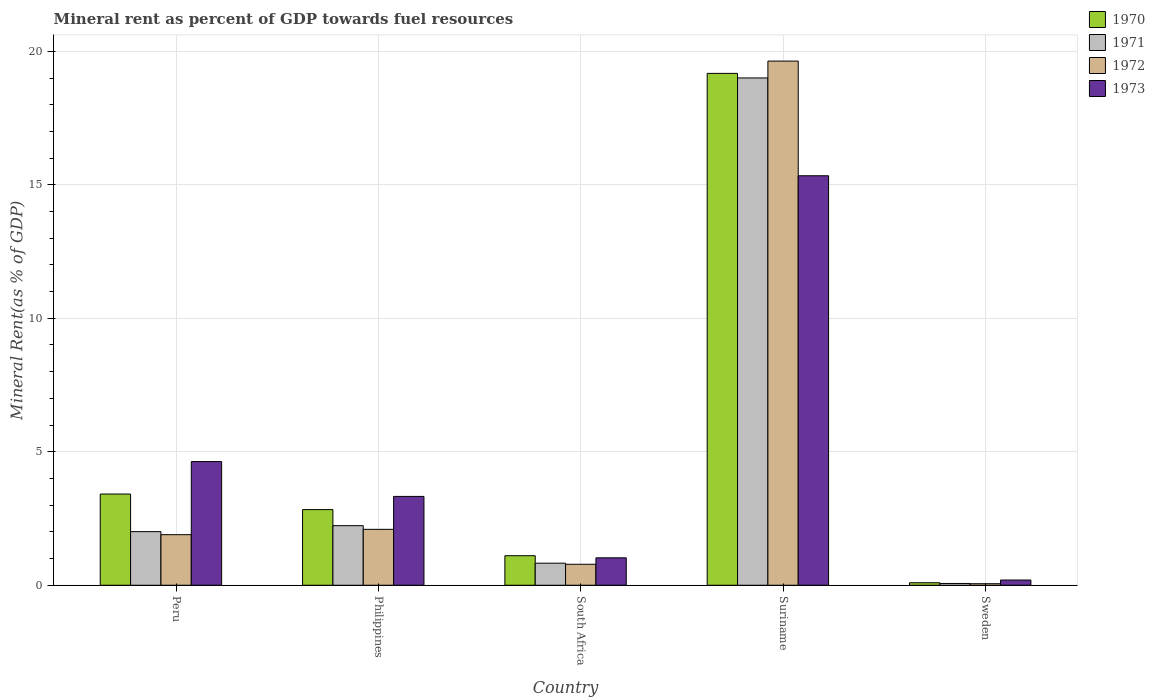How many different coloured bars are there?
Provide a succinct answer. 4. How many groups of bars are there?
Make the answer very short. 5. Are the number of bars per tick equal to the number of legend labels?
Keep it short and to the point. Yes. Are the number of bars on each tick of the X-axis equal?
Ensure brevity in your answer.  Yes. How many bars are there on the 3rd tick from the left?
Your response must be concise. 4. How many bars are there on the 5th tick from the right?
Provide a succinct answer. 4. What is the label of the 3rd group of bars from the left?
Provide a short and direct response. South Africa. In how many cases, is the number of bars for a given country not equal to the number of legend labels?
Give a very brief answer. 0. What is the mineral rent in 1972 in Sweden?
Ensure brevity in your answer.  0.06. Across all countries, what is the maximum mineral rent in 1972?
Keep it short and to the point. 19.63. Across all countries, what is the minimum mineral rent in 1970?
Provide a short and direct response. 0.09. In which country was the mineral rent in 1972 maximum?
Make the answer very short. Suriname. In which country was the mineral rent in 1970 minimum?
Give a very brief answer. Sweden. What is the total mineral rent in 1970 in the graph?
Your response must be concise. 26.62. What is the difference between the mineral rent in 1972 in South Africa and that in Suriname?
Your answer should be very brief. -18.85. What is the difference between the mineral rent in 1971 in Peru and the mineral rent in 1970 in Philippines?
Your answer should be very brief. -0.83. What is the average mineral rent in 1971 per country?
Give a very brief answer. 4.83. What is the difference between the mineral rent of/in 1973 and mineral rent of/in 1972 in South Africa?
Keep it short and to the point. 0.24. What is the ratio of the mineral rent in 1973 in Philippines to that in Suriname?
Ensure brevity in your answer.  0.22. Is the mineral rent in 1971 in South Africa less than that in Sweden?
Keep it short and to the point. No. What is the difference between the highest and the second highest mineral rent in 1970?
Your response must be concise. 0.58. What is the difference between the highest and the lowest mineral rent in 1972?
Your response must be concise. 19.58. In how many countries, is the mineral rent in 1972 greater than the average mineral rent in 1972 taken over all countries?
Provide a short and direct response. 1. Is the sum of the mineral rent in 1973 in South Africa and Sweden greater than the maximum mineral rent in 1972 across all countries?
Your answer should be compact. No. What does the 1st bar from the left in Suriname represents?
Provide a succinct answer. 1970. How many bars are there?
Make the answer very short. 20. How many countries are there in the graph?
Provide a short and direct response. 5. Does the graph contain grids?
Provide a short and direct response. Yes. How many legend labels are there?
Your response must be concise. 4. How are the legend labels stacked?
Offer a terse response. Vertical. What is the title of the graph?
Offer a terse response. Mineral rent as percent of GDP towards fuel resources. Does "2001" appear as one of the legend labels in the graph?
Your answer should be very brief. No. What is the label or title of the X-axis?
Offer a very short reply. Country. What is the label or title of the Y-axis?
Offer a terse response. Mineral Rent(as % of GDP). What is the Mineral Rent(as % of GDP) of 1970 in Peru?
Offer a terse response. 3.42. What is the Mineral Rent(as % of GDP) of 1971 in Peru?
Keep it short and to the point. 2.01. What is the Mineral Rent(as % of GDP) of 1972 in Peru?
Your response must be concise. 1.89. What is the Mineral Rent(as % of GDP) in 1973 in Peru?
Provide a succinct answer. 4.63. What is the Mineral Rent(as % of GDP) of 1970 in Philippines?
Your response must be concise. 2.83. What is the Mineral Rent(as % of GDP) of 1971 in Philippines?
Provide a succinct answer. 2.23. What is the Mineral Rent(as % of GDP) of 1972 in Philippines?
Keep it short and to the point. 2.09. What is the Mineral Rent(as % of GDP) of 1973 in Philippines?
Your answer should be compact. 3.33. What is the Mineral Rent(as % of GDP) of 1970 in South Africa?
Offer a very short reply. 1.11. What is the Mineral Rent(as % of GDP) in 1971 in South Africa?
Provide a short and direct response. 0.83. What is the Mineral Rent(as % of GDP) in 1972 in South Africa?
Make the answer very short. 0.79. What is the Mineral Rent(as % of GDP) in 1973 in South Africa?
Ensure brevity in your answer.  1.03. What is the Mineral Rent(as % of GDP) in 1970 in Suriname?
Offer a terse response. 19.17. What is the Mineral Rent(as % of GDP) of 1971 in Suriname?
Your response must be concise. 19. What is the Mineral Rent(as % of GDP) of 1972 in Suriname?
Offer a terse response. 19.63. What is the Mineral Rent(as % of GDP) in 1973 in Suriname?
Your answer should be very brief. 15.34. What is the Mineral Rent(as % of GDP) of 1970 in Sweden?
Your answer should be compact. 0.09. What is the Mineral Rent(as % of GDP) of 1971 in Sweden?
Provide a succinct answer. 0.07. What is the Mineral Rent(as % of GDP) in 1972 in Sweden?
Your answer should be very brief. 0.06. What is the Mineral Rent(as % of GDP) in 1973 in Sweden?
Offer a very short reply. 0.2. Across all countries, what is the maximum Mineral Rent(as % of GDP) in 1970?
Your response must be concise. 19.17. Across all countries, what is the maximum Mineral Rent(as % of GDP) in 1971?
Your response must be concise. 19. Across all countries, what is the maximum Mineral Rent(as % of GDP) in 1972?
Make the answer very short. 19.63. Across all countries, what is the maximum Mineral Rent(as % of GDP) in 1973?
Your answer should be very brief. 15.34. Across all countries, what is the minimum Mineral Rent(as % of GDP) of 1970?
Give a very brief answer. 0.09. Across all countries, what is the minimum Mineral Rent(as % of GDP) in 1971?
Offer a very short reply. 0.07. Across all countries, what is the minimum Mineral Rent(as % of GDP) of 1972?
Offer a very short reply. 0.06. Across all countries, what is the minimum Mineral Rent(as % of GDP) of 1973?
Provide a short and direct response. 0.2. What is the total Mineral Rent(as % of GDP) in 1970 in the graph?
Give a very brief answer. 26.62. What is the total Mineral Rent(as % of GDP) in 1971 in the graph?
Offer a very short reply. 24.13. What is the total Mineral Rent(as % of GDP) in 1972 in the graph?
Your answer should be compact. 24.46. What is the total Mineral Rent(as % of GDP) in 1973 in the graph?
Give a very brief answer. 24.52. What is the difference between the Mineral Rent(as % of GDP) of 1970 in Peru and that in Philippines?
Give a very brief answer. 0.58. What is the difference between the Mineral Rent(as % of GDP) of 1971 in Peru and that in Philippines?
Your answer should be compact. -0.22. What is the difference between the Mineral Rent(as % of GDP) of 1972 in Peru and that in Philippines?
Make the answer very short. -0.2. What is the difference between the Mineral Rent(as % of GDP) of 1973 in Peru and that in Philippines?
Your answer should be compact. 1.31. What is the difference between the Mineral Rent(as % of GDP) of 1970 in Peru and that in South Africa?
Your answer should be compact. 2.31. What is the difference between the Mineral Rent(as % of GDP) in 1971 in Peru and that in South Africa?
Give a very brief answer. 1.18. What is the difference between the Mineral Rent(as % of GDP) in 1972 in Peru and that in South Africa?
Your response must be concise. 1.11. What is the difference between the Mineral Rent(as % of GDP) of 1973 in Peru and that in South Africa?
Your answer should be very brief. 3.61. What is the difference between the Mineral Rent(as % of GDP) of 1970 in Peru and that in Suriname?
Ensure brevity in your answer.  -15.76. What is the difference between the Mineral Rent(as % of GDP) of 1971 in Peru and that in Suriname?
Give a very brief answer. -16.99. What is the difference between the Mineral Rent(as % of GDP) in 1972 in Peru and that in Suriname?
Offer a very short reply. -17.74. What is the difference between the Mineral Rent(as % of GDP) of 1973 in Peru and that in Suriname?
Keep it short and to the point. -10.71. What is the difference between the Mineral Rent(as % of GDP) of 1970 in Peru and that in Sweden?
Ensure brevity in your answer.  3.32. What is the difference between the Mineral Rent(as % of GDP) in 1971 in Peru and that in Sweden?
Your answer should be compact. 1.94. What is the difference between the Mineral Rent(as % of GDP) of 1972 in Peru and that in Sweden?
Provide a succinct answer. 1.84. What is the difference between the Mineral Rent(as % of GDP) of 1973 in Peru and that in Sweden?
Offer a very short reply. 4.44. What is the difference between the Mineral Rent(as % of GDP) in 1970 in Philippines and that in South Africa?
Provide a succinct answer. 1.73. What is the difference between the Mineral Rent(as % of GDP) in 1971 in Philippines and that in South Africa?
Provide a short and direct response. 1.41. What is the difference between the Mineral Rent(as % of GDP) of 1972 in Philippines and that in South Africa?
Your answer should be very brief. 1.31. What is the difference between the Mineral Rent(as % of GDP) in 1973 in Philippines and that in South Africa?
Offer a terse response. 2.3. What is the difference between the Mineral Rent(as % of GDP) of 1970 in Philippines and that in Suriname?
Ensure brevity in your answer.  -16.34. What is the difference between the Mineral Rent(as % of GDP) of 1971 in Philippines and that in Suriname?
Offer a very short reply. -16.77. What is the difference between the Mineral Rent(as % of GDP) in 1972 in Philippines and that in Suriname?
Offer a terse response. -17.54. What is the difference between the Mineral Rent(as % of GDP) in 1973 in Philippines and that in Suriname?
Your answer should be very brief. -12.01. What is the difference between the Mineral Rent(as % of GDP) of 1970 in Philippines and that in Sweden?
Your answer should be compact. 2.74. What is the difference between the Mineral Rent(as % of GDP) of 1971 in Philippines and that in Sweden?
Your answer should be compact. 2.17. What is the difference between the Mineral Rent(as % of GDP) in 1972 in Philippines and that in Sweden?
Ensure brevity in your answer.  2.04. What is the difference between the Mineral Rent(as % of GDP) of 1973 in Philippines and that in Sweden?
Provide a short and direct response. 3.13. What is the difference between the Mineral Rent(as % of GDP) in 1970 in South Africa and that in Suriname?
Provide a short and direct response. -18.07. What is the difference between the Mineral Rent(as % of GDP) in 1971 in South Africa and that in Suriname?
Make the answer very short. -18.18. What is the difference between the Mineral Rent(as % of GDP) of 1972 in South Africa and that in Suriname?
Provide a short and direct response. -18.85. What is the difference between the Mineral Rent(as % of GDP) of 1973 in South Africa and that in Suriname?
Ensure brevity in your answer.  -14.31. What is the difference between the Mineral Rent(as % of GDP) of 1970 in South Africa and that in Sweden?
Give a very brief answer. 1.01. What is the difference between the Mineral Rent(as % of GDP) in 1971 in South Africa and that in Sweden?
Your answer should be very brief. 0.76. What is the difference between the Mineral Rent(as % of GDP) of 1972 in South Africa and that in Sweden?
Provide a succinct answer. 0.73. What is the difference between the Mineral Rent(as % of GDP) of 1973 in South Africa and that in Sweden?
Provide a succinct answer. 0.83. What is the difference between the Mineral Rent(as % of GDP) of 1970 in Suriname and that in Sweden?
Give a very brief answer. 19.08. What is the difference between the Mineral Rent(as % of GDP) of 1971 in Suriname and that in Sweden?
Make the answer very short. 18.94. What is the difference between the Mineral Rent(as % of GDP) in 1972 in Suriname and that in Sweden?
Offer a very short reply. 19.58. What is the difference between the Mineral Rent(as % of GDP) in 1973 in Suriname and that in Sweden?
Give a very brief answer. 15.14. What is the difference between the Mineral Rent(as % of GDP) of 1970 in Peru and the Mineral Rent(as % of GDP) of 1971 in Philippines?
Give a very brief answer. 1.18. What is the difference between the Mineral Rent(as % of GDP) of 1970 in Peru and the Mineral Rent(as % of GDP) of 1972 in Philippines?
Keep it short and to the point. 1.32. What is the difference between the Mineral Rent(as % of GDP) of 1970 in Peru and the Mineral Rent(as % of GDP) of 1973 in Philippines?
Provide a succinct answer. 0.09. What is the difference between the Mineral Rent(as % of GDP) in 1971 in Peru and the Mineral Rent(as % of GDP) in 1972 in Philippines?
Provide a succinct answer. -0.09. What is the difference between the Mineral Rent(as % of GDP) in 1971 in Peru and the Mineral Rent(as % of GDP) in 1973 in Philippines?
Provide a succinct answer. -1.32. What is the difference between the Mineral Rent(as % of GDP) in 1972 in Peru and the Mineral Rent(as % of GDP) in 1973 in Philippines?
Keep it short and to the point. -1.43. What is the difference between the Mineral Rent(as % of GDP) in 1970 in Peru and the Mineral Rent(as % of GDP) in 1971 in South Africa?
Your answer should be compact. 2.59. What is the difference between the Mineral Rent(as % of GDP) in 1970 in Peru and the Mineral Rent(as % of GDP) in 1972 in South Africa?
Your response must be concise. 2.63. What is the difference between the Mineral Rent(as % of GDP) in 1970 in Peru and the Mineral Rent(as % of GDP) in 1973 in South Africa?
Your answer should be very brief. 2.39. What is the difference between the Mineral Rent(as % of GDP) of 1971 in Peru and the Mineral Rent(as % of GDP) of 1972 in South Africa?
Your answer should be compact. 1.22. What is the difference between the Mineral Rent(as % of GDP) of 1971 in Peru and the Mineral Rent(as % of GDP) of 1973 in South Africa?
Provide a short and direct response. 0.98. What is the difference between the Mineral Rent(as % of GDP) of 1972 in Peru and the Mineral Rent(as % of GDP) of 1973 in South Africa?
Offer a very short reply. 0.87. What is the difference between the Mineral Rent(as % of GDP) in 1970 in Peru and the Mineral Rent(as % of GDP) in 1971 in Suriname?
Your answer should be very brief. -15.59. What is the difference between the Mineral Rent(as % of GDP) of 1970 in Peru and the Mineral Rent(as % of GDP) of 1972 in Suriname?
Your answer should be compact. -16.22. What is the difference between the Mineral Rent(as % of GDP) of 1970 in Peru and the Mineral Rent(as % of GDP) of 1973 in Suriname?
Make the answer very short. -11.92. What is the difference between the Mineral Rent(as % of GDP) in 1971 in Peru and the Mineral Rent(as % of GDP) in 1972 in Suriname?
Give a very brief answer. -17.63. What is the difference between the Mineral Rent(as % of GDP) of 1971 in Peru and the Mineral Rent(as % of GDP) of 1973 in Suriname?
Provide a succinct answer. -13.33. What is the difference between the Mineral Rent(as % of GDP) in 1972 in Peru and the Mineral Rent(as % of GDP) in 1973 in Suriname?
Make the answer very short. -13.44. What is the difference between the Mineral Rent(as % of GDP) in 1970 in Peru and the Mineral Rent(as % of GDP) in 1971 in Sweden?
Offer a very short reply. 3.35. What is the difference between the Mineral Rent(as % of GDP) in 1970 in Peru and the Mineral Rent(as % of GDP) in 1972 in Sweden?
Your response must be concise. 3.36. What is the difference between the Mineral Rent(as % of GDP) of 1970 in Peru and the Mineral Rent(as % of GDP) of 1973 in Sweden?
Your answer should be compact. 3.22. What is the difference between the Mineral Rent(as % of GDP) in 1971 in Peru and the Mineral Rent(as % of GDP) in 1972 in Sweden?
Keep it short and to the point. 1.95. What is the difference between the Mineral Rent(as % of GDP) of 1971 in Peru and the Mineral Rent(as % of GDP) of 1973 in Sweden?
Offer a terse response. 1.81. What is the difference between the Mineral Rent(as % of GDP) of 1972 in Peru and the Mineral Rent(as % of GDP) of 1973 in Sweden?
Provide a short and direct response. 1.7. What is the difference between the Mineral Rent(as % of GDP) in 1970 in Philippines and the Mineral Rent(as % of GDP) in 1971 in South Africa?
Make the answer very short. 2.01. What is the difference between the Mineral Rent(as % of GDP) of 1970 in Philippines and the Mineral Rent(as % of GDP) of 1972 in South Africa?
Make the answer very short. 2.05. What is the difference between the Mineral Rent(as % of GDP) of 1970 in Philippines and the Mineral Rent(as % of GDP) of 1973 in South Africa?
Provide a succinct answer. 1.81. What is the difference between the Mineral Rent(as % of GDP) of 1971 in Philippines and the Mineral Rent(as % of GDP) of 1972 in South Africa?
Offer a terse response. 1.45. What is the difference between the Mineral Rent(as % of GDP) in 1971 in Philippines and the Mineral Rent(as % of GDP) in 1973 in South Africa?
Provide a short and direct response. 1.2. What is the difference between the Mineral Rent(as % of GDP) in 1972 in Philippines and the Mineral Rent(as % of GDP) in 1973 in South Africa?
Ensure brevity in your answer.  1.07. What is the difference between the Mineral Rent(as % of GDP) in 1970 in Philippines and the Mineral Rent(as % of GDP) in 1971 in Suriname?
Your answer should be very brief. -16.17. What is the difference between the Mineral Rent(as % of GDP) in 1970 in Philippines and the Mineral Rent(as % of GDP) in 1972 in Suriname?
Offer a terse response. -16.8. What is the difference between the Mineral Rent(as % of GDP) of 1970 in Philippines and the Mineral Rent(as % of GDP) of 1973 in Suriname?
Make the answer very short. -12.51. What is the difference between the Mineral Rent(as % of GDP) of 1971 in Philippines and the Mineral Rent(as % of GDP) of 1972 in Suriname?
Offer a terse response. -17.4. What is the difference between the Mineral Rent(as % of GDP) of 1971 in Philippines and the Mineral Rent(as % of GDP) of 1973 in Suriname?
Ensure brevity in your answer.  -13.11. What is the difference between the Mineral Rent(as % of GDP) of 1972 in Philippines and the Mineral Rent(as % of GDP) of 1973 in Suriname?
Make the answer very short. -13.24. What is the difference between the Mineral Rent(as % of GDP) in 1970 in Philippines and the Mineral Rent(as % of GDP) in 1971 in Sweden?
Give a very brief answer. 2.77. What is the difference between the Mineral Rent(as % of GDP) of 1970 in Philippines and the Mineral Rent(as % of GDP) of 1972 in Sweden?
Provide a short and direct response. 2.78. What is the difference between the Mineral Rent(as % of GDP) of 1970 in Philippines and the Mineral Rent(as % of GDP) of 1973 in Sweden?
Offer a very short reply. 2.64. What is the difference between the Mineral Rent(as % of GDP) in 1971 in Philippines and the Mineral Rent(as % of GDP) in 1972 in Sweden?
Your response must be concise. 2.17. What is the difference between the Mineral Rent(as % of GDP) of 1971 in Philippines and the Mineral Rent(as % of GDP) of 1973 in Sweden?
Your answer should be compact. 2.04. What is the difference between the Mineral Rent(as % of GDP) in 1972 in Philippines and the Mineral Rent(as % of GDP) in 1973 in Sweden?
Your answer should be compact. 1.9. What is the difference between the Mineral Rent(as % of GDP) in 1970 in South Africa and the Mineral Rent(as % of GDP) in 1971 in Suriname?
Your answer should be compact. -17.9. What is the difference between the Mineral Rent(as % of GDP) of 1970 in South Africa and the Mineral Rent(as % of GDP) of 1972 in Suriname?
Give a very brief answer. -18.53. What is the difference between the Mineral Rent(as % of GDP) in 1970 in South Africa and the Mineral Rent(as % of GDP) in 1973 in Suriname?
Your answer should be compact. -14.23. What is the difference between the Mineral Rent(as % of GDP) in 1971 in South Africa and the Mineral Rent(as % of GDP) in 1972 in Suriname?
Your answer should be compact. -18.81. What is the difference between the Mineral Rent(as % of GDP) in 1971 in South Africa and the Mineral Rent(as % of GDP) in 1973 in Suriname?
Provide a succinct answer. -14.51. What is the difference between the Mineral Rent(as % of GDP) of 1972 in South Africa and the Mineral Rent(as % of GDP) of 1973 in Suriname?
Give a very brief answer. -14.55. What is the difference between the Mineral Rent(as % of GDP) in 1970 in South Africa and the Mineral Rent(as % of GDP) in 1971 in Sweden?
Your answer should be very brief. 1.04. What is the difference between the Mineral Rent(as % of GDP) in 1970 in South Africa and the Mineral Rent(as % of GDP) in 1972 in Sweden?
Keep it short and to the point. 1.05. What is the difference between the Mineral Rent(as % of GDP) of 1970 in South Africa and the Mineral Rent(as % of GDP) of 1973 in Sweden?
Keep it short and to the point. 0.91. What is the difference between the Mineral Rent(as % of GDP) of 1971 in South Africa and the Mineral Rent(as % of GDP) of 1972 in Sweden?
Your answer should be very brief. 0.77. What is the difference between the Mineral Rent(as % of GDP) of 1971 in South Africa and the Mineral Rent(as % of GDP) of 1973 in Sweden?
Your answer should be compact. 0.63. What is the difference between the Mineral Rent(as % of GDP) of 1972 in South Africa and the Mineral Rent(as % of GDP) of 1973 in Sweden?
Ensure brevity in your answer.  0.59. What is the difference between the Mineral Rent(as % of GDP) in 1970 in Suriname and the Mineral Rent(as % of GDP) in 1971 in Sweden?
Give a very brief answer. 19.11. What is the difference between the Mineral Rent(as % of GDP) in 1970 in Suriname and the Mineral Rent(as % of GDP) in 1972 in Sweden?
Ensure brevity in your answer.  19.12. What is the difference between the Mineral Rent(as % of GDP) in 1970 in Suriname and the Mineral Rent(as % of GDP) in 1973 in Sweden?
Offer a terse response. 18.98. What is the difference between the Mineral Rent(as % of GDP) of 1971 in Suriname and the Mineral Rent(as % of GDP) of 1972 in Sweden?
Give a very brief answer. 18.95. What is the difference between the Mineral Rent(as % of GDP) of 1971 in Suriname and the Mineral Rent(as % of GDP) of 1973 in Sweden?
Keep it short and to the point. 18.81. What is the difference between the Mineral Rent(as % of GDP) in 1972 in Suriname and the Mineral Rent(as % of GDP) in 1973 in Sweden?
Provide a succinct answer. 19.44. What is the average Mineral Rent(as % of GDP) in 1970 per country?
Offer a very short reply. 5.32. What is the average Mineral Rent(as % of GDP) of 1971 per country?
Provide a succinct answer. 4.83. What is the average Mineral Rent(as % of GDP) of 1972 per country?
Make the answer very short. 4.89. What is the average Mineral Rent(as % of GDP) of 1973 per country?
Ensure brevity in your answer.  4.9. What is the difference between the Mineral Rent(as % of GDP) of 1970 and Mineral Rent(as % of GDP) of 1971 in Peru?
Provide a succinct answer. 1.41. What is the difference between the Mineral Rent(as % of GDP) in 1970 and Mineral Rent(as % of GDP) in 1972 in Peru?
Make the answer very short. 1.52. What is the difference between the Mineral Rent(as % of GDP) in 1970 and Mineral Rent(as % of GDP) in 1973 in Peru?
Your answer should be very brief. -1.22. What is the difference between the Mineral Rent(as % of GDP) of 1971 and Mineral Rent(as % of GDP) of 1972 in Peru?
Your answer should be very brief. 0.11. What is the difference between the Mineral Rent(as % of GDP) in 1971 and Mineral Rent(as % of GDP) in 1973 in Peru?
Give a very brief answer. -2.62. What is the difference between the Mineral Rent(as % of GDP) of 1972 and Mineral Rent(as % of GDP) of 1973 in Peru?
Your response must be concise. -2.74. What is the difference between the Mineral Rent(as % of GDP) of 1970 and Mineral Rent(as % of GDP) of 1971 in Philippines?
Keep it short and to the point. 0.6. What is the difference between the Mineral Rent(as % of GDP) in 1970 and Mineral Rent(as % of GDP) in 1972 in Philippines?
Keep it short and to the point. 0.74. What is the difference between the Mineral Rent(as % of GDP) of 1970 and Mineral Rent(as % of GDP) of 1973 in Philippines?
Provide a short and direct response. -0.49. What is the difference between the Mineral Rent(as % of GDP) in 1971 and Mineral Rent(as % of GDP) in 1972 in Philippines?
Give a very brief answer. 0.14. What is the difference between the Mineral Rent(as % of GDP) of 1971 and Mineral Rent(as % of GDP) of 1973 in Philippines?
Give a very brief answer. -1.1. What is the difference between the Mineral Rent(as % of GDP) in 1972 and Mineral Rent(as % of GDP) in 1973 in Philippines?
Make the answer very short. -1.23. What is the difference between the Mineral Rent(as % of GDP) of 1970 and Mineral Rent(as % of GDP) of 1971 in South Africa?
Offer a very short reply. 0.28. What is the difference between the Mineral Rent(as % of GDP) of 1970 and Mineral Rent(as % of GDP) of 1972 in South Africa?
Ensure brevity in your answer.  0.32. What is the difference between the Mineral Rent(as % of GDP) in 1970 and Mineral Rent(as % of GDP) in 1973 in South Africa?
Keep it short and to the point. 0.08. What is the difference between the Mineral Rent(as % of GDP) of 1971 and Mineral Rent(as % of GDP) of 1972 in South Africa?
Provide a short and direct response. 0.04. What is the difference between the Mineral Rent(as % of GDP) of 1971 and Mineral Rent(as % of GDP) of 1973 in South Africa?
Give a very brief answer. -0.2. What is the difference between the Mineral Rent(as % of GDP) of 1972 and Mineral Rent(as % of GDP) of 1973 in South Africa?
Give a very brief answer. -0.24. What is the difference between the Mineral Rent(as % of GDP) of 1970 and Mineral Rent(as % of GDP) of 1971 in Suriname?
Keep it short and to the point. 0.17. What is the difference between the Mineral Rent(as % of GDP) of 1970 and Mineral Rent(as % of GDP) of 1972 in Suriname?
Provide a succinct answer. -0.46. What is the difference between the Mineral Rent(as % of GDP) of 1970 and Mineral Rent(as % of GDP) of 1973 in Suriname?
Keep it short and to the point. 3.84. What is the difference between the Mineral Rent(as % of GDP) in 1971 and Mineral Rent(as % of GDP) in 1972 in Suriname?
Your response must be concise. -0.63. What is the difference between the Mineral Rent(as % of GDP) of 1971 and Mineral Rent(as % of GDP) of 1973 in Suriname?
Offer a terse response. 3.66. What is the difference between the Mineral Rent(as % of GDP) in 1972 and Mineral Rent(as % of GDP) in 1973 in Suriname?
Provide a short and direct response. 4.3. What is the difference between the Mineral Rent(as % of GDP) of 1970 and Mineral Rent(as % of GDP) of 1971 in Sweden?
Your answer should be compact. 0.03. What is the difference between the Mineral Rent(as % of GDP) in 1970 and Mineral Rent(as % of GDP) in 1972 in Sweden?
Give a very brief answer. 0.04. What is the difference between the Mineral Rent(as % of GDP) of 1970 and Mineral Rent(as % of GDP) of 1973 in Sweden?
Offer a very short reply. -0.1. What is the difference between the Mineral Rent(as % of GDP) of 1971 and Mineral Rent(as % of GDP) of 1972 in Sweden?
Keep it short and to the point. 0.01. What is the difference between the Mineral Rent(as % of GDP) in 1971 and Mineral Rent(as % of GDP) in 1973 in Sweden?
Ensure brevity in your answer.  -0.13. What is the difference between the Mineral Rent(as % of GDP) of 1972 and Mineral Rent(as % of GDP) of 1973 in Sweden?
Your response must be concise. -0.14. What is the ratio of the Mineral Rent(as % of GDP) of 1970 in Peru to that in Philippines?
Keep it short and to the point. 1.21. What is the ratio of the Mineral Rent(as % of GDP) in 1971 in Peru to that in Philippines?
Offer a very short reply. 0.9. What is the ratio of the Mineral Rent(as % of GDP) of 1972 in Peru to that in Philippines?
Offer a terse response. 0.9. What is the ratio of the Mineral Rent(as % of GDP) of 1973 in Peru to that in Philippines?
Offer a very short reply. 1.39. What is the ratio of the Mineral Rent(as % of GDP) of 1970 in Peru to that in South Africa?
Make the answer very short. 3.09. What is the ratio of the Mineral Rent(as % of GDP) of 1971 in Peru to that in South Africa?
Ensure brevity in your answer.  2.43. What is the ratio of the Mineral Rent(as % of GDP) of 1972 in Peru to that in South Africa?
Make the answer very short. 2.41. What is the ratio of the Mineral Rent(as % of GDP) of 1973 in Peru to that in South Africa?
Ensure brevity in your answer.  4.51. What is the ratio of the Mineral Rent(as % of GDP) of 1970 in Peru to that in Suriname?
Offer a terse response. 0.18. What is the ratio of the Mineral Rent(as % of GDP) in 1971 in Peru to that in Suriname?
Provide a short and direct response. 0.11. What is the ratio of the Mineral Rent(as % of GDP) in 1972 in Peru to that in Suriname?
Ensure brevity in your answer.  0.1. What is the ratio of the Mineral Rent(as % of GDP) of 1973 in Peru to that in Suriname?
Keep it short and to the point. 0.3. What is the ratio of the Mineral Rent(as % of GDP) in 1970 in Peru to that in Sweden?
Your answer should be compact. 36.88. What is the ratio of the Mineral Rent(as % of GDP) of 1971 in Peru to that in Sweden?
Provide a succinct answer. 30.33. What is the ratio of the Mineral Rent(as % of GDP) in 1972 in Peru to that in Sweden?
Provide a short and direct response. 32.98. What is the ratio of the Mineral Rent(as % of GDP) in 1973 in Peru to that in Sweden?
Offer a very short reply. 23.72. What is the ratio of the Mineral Rent(as % of GDP) of 1970 in Philippines to that in South Africa?
Provide a succinct answer. 2.56. What is the ratio of the Mineral Rent(as % of GDP) in 1971 in Philippines to that in South Africa?
Your answer should be very brief. 2.7. What is the ratio of the Mineral Rent(as % of GDP) in 1972 in Philippines to that in South Africa?
Offer a very short reply. 2.67. What is the ratio of the Mineral Rent(as % of GDP) in 1973 in Philippines to that in South Africa?
Provide a short and direct response. 3.24. What is the ratio of the Mineral Rent(as % of GDP) in 1970 in Philippines to that in Suriname?
Offer a very short reply. 0.15. What is the ratio of the Mineral Rent(as % of GDP) in 1971 in Philippines to that in Suriname?
Provide a succinct answer. 0.12. What is the ratio of the Mineral Rent(as % of GDP) in 1972 in Philippines to that in Suriname?
Offer a very short reply. 0.11. What is the ratio of the Mineral Rent(as % of GDP) of 1973 in Philippines to that in Suriname?
Offer a very short reply. 0.22. What is the ratio of the Mineral Rent(as % of GDP) of 1970 in Philippines to that in Sweden?
Offer a terse response. 30.59. What is the ratio of the Mineral Rent(as % of GDP) of 1971 in Philippines to that in Sweden?
Keep it short and to the point. 33.7. What is the ratio of the Mineral Rent(as % of GDP) in 1972 in Philippines to that in Sweden?
Ensure brevity in your answer.  36.47. What is the ratio of the Mineral Rent(as % of GDP) of 1973 in Philippines to that in Sweden?
Provide a succinct answer. 17.03. What is the ratio of the Mineral Rent(as % of GDP) in 1970 in South Africa to that in Suriname?
Your response must be concise. 0.06. What is the ratio of the Mineral Rent(as % of GDP) of 1971 in South Africa to that in Suriname?
Your response must be concise. 0.04. What is the ratio of the Mineral Rent(as % of GDP) of 1972 in South Africa to that in Suriname?
Your response must be concise. 0.04. What is the ratio of the Mineral Rent(as % of GDP) in 1973 in South Africa to that in Suriname?
Ensure brevity in your answer.  0.07. What is the ratio of the Mineral Rent(as % of GDP) of 1970 in South Africa to that in Sweden?
Give a very brief answer. 11.94. What is the ratio of the Mineral Rent(as % of GDP) in 1971 in South Africa to that in Sweden?
Your response must be concise. 12.48. What is the ratio of the Mineral Rent(as % of GDP) in 1972 in South Africa to that in Sweden?
Your answer should be compact. 13.67. What is the ratio of the Mineral Rent(as % of GDP) of 1973 in South Africa to that in Sweden?
Provide a succinct answer. 5.26. What is the ratio of the Mineral Rent(as % of GDP) of 1970 in Suriname to that in Sweden?
Give a very brief answer. 207. What is the ratio of the Mineral Rent(as % of GDP) in 1971 in Suriname to that in Sweden?
Make the answer very short. 287. What is the ratio of the Mineral Rent(as % of GDP) of 1972 in Suriname to that in Sweden?
Keep it short and to the point. 341.94. What is the ratio of the Mineral Rent(as % of GDP) in 1973 in Suriname to that in Sweden?
Offer a very short reply. 78.52. What is the difference between the highest and the second highest Mineral Rent(as % of GDP) of 1970?
Keep it short and to the point. 15.76. What is the difference between the highest and the second highest Mineral Rent(as % of GDP) of 1971?
Your answer should be very brief. 16.77. What is the difference between the highest and the second highest Mineral Rent(as % of GDP) of 1972?
Provide a succinct answer. 17.54. What is the difference between the highest and the second highest Mineral Rent(as % of GDP) of 1973?
Provide a short and direct response. 10.71. What is the difference between the highest and the lowest Mineral Rent(as % of GDP) of 1970?
Offer a very short reply. 19.08. What is the difference between the highest and the lowest Mineral Rent(as % of GDP) of 1971?
Your response must be concise. 18.94. What is the difference between the highest and the lowest Mineral Rent(as % of GDP) of 1972?
Your answer should be very brief. 19.58. What is the difference between the highest and the lowest Mineral Rent(as % of GDP) of 1973?
Provide a short and direct response. 15.14. 